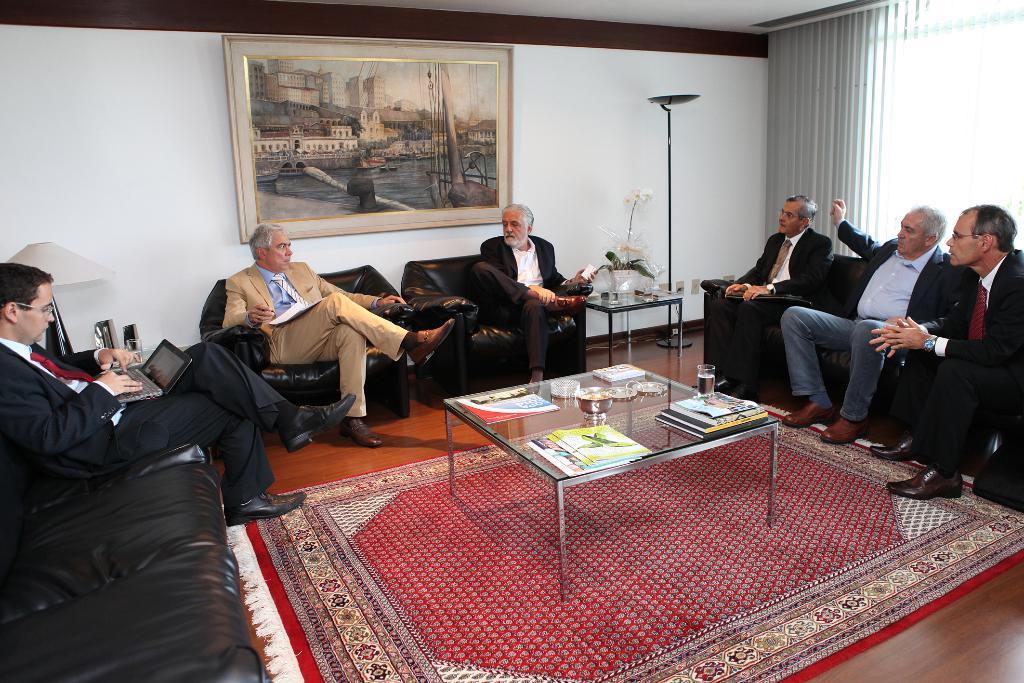Describe this image in one or two sentences. Here we can see few persons are sitting on the chairs and sofas. On the left there is a laptop on a person thighs. In the middle there is a glass with water and other objects on a table on the carpet on a floor. In the background there is a frame on the wall,lamp,flower vase on a table,stand,shutter blinds and a window. 